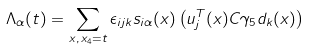Convert formula to latex. <formula><loc_0><loc_0><loc_500><loc_500>\Lambda _ { \alpha } ( t ) = \sum _ { x , \, x _ { 4 } = t } \epsilon _ { i j k } s _ { i \alpha } ( x ) \left ( u _ { j } ^ { T } ( x ) C \gamma _ { 5 } d _ { k } ( x ) \right )</formula> 